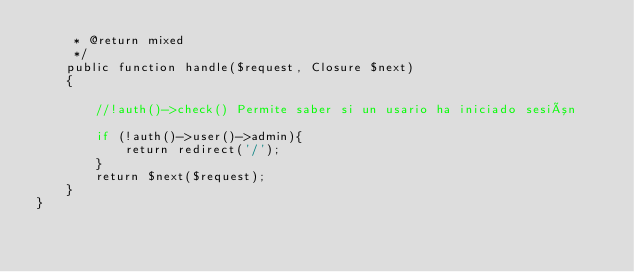Convert code to text. <code><loc_0><loc_0><loc_500><loc_500><_PHP_>     * @return mixed
     */
    public function handle($request, Closure $next)
    {
        
        //!auth()->check() Permite saber si un usario ha iniciado sesión
      
        if (!auth()->user()->admin){
            return redirect('/');
        }
        return $next($request);
    }
}
</code> 